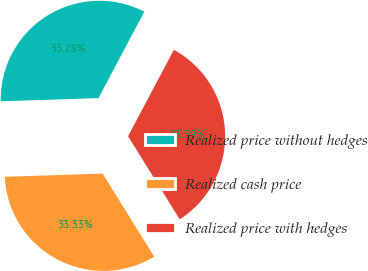Convert chart. <chart><loc_0><loc_0><loc_500><loc_500><pie_chart><fcel>Realized price without hedges<fcel>Realized cash price<fcel>Realized price with hedges<nl><fcel>33.28%<fcel>33.33%<fcel>33.39%<nl></chart> 